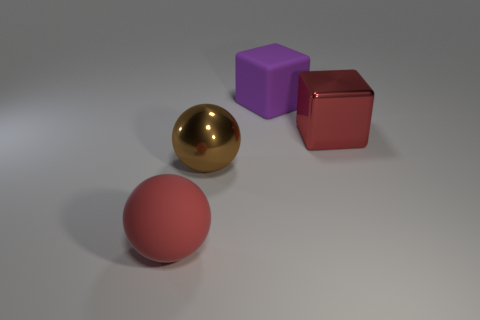Does the shiny cube have the same color as the large rubber sphere?
Offer a terse response. Yes. There is a object that is behind the brown thing and in front of the purple cube; what is its size?
Offer a very short reply. Large. The object that is right of the brown shiny object and in front of the purple block is what color?
Provide a short and direct response. Red. Are there fewer big rubber blocks in front of the purple cube than large rubber blocks that are left of the red shiny thing?
Your response must be concise. Yes. What number of other large matte things are the same shape as the purple rubber object?
Offer a very short reply. 0. What size is the red sphere that is made of the same material as the purple block?
Ensure brevity in your answer.  Large. What color is the big metallic thing that is in front of the shiny object that is to the right of the big purple rubber block?
Offer a very short reply. Brown. There is a red metal object; is it the same shape as the big rubber object that is behind the brown shiny ball?
Offer a very short reply. Yes. How many purple shiny blocks are the same size as the brown ball?
Provide a succinct answer. 0. There is a red thing that is the same shape as the purple matte object; what is its material?
Your answer should be compact. Metal. 